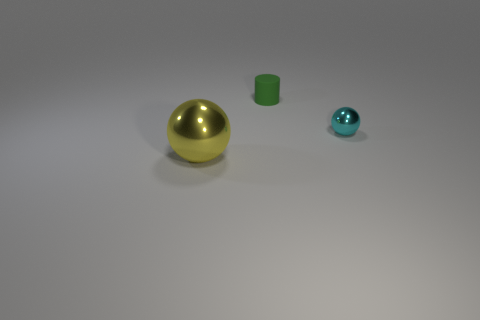What number of blocks are small yellow things or large yellow metallic things? In the image, there are no blocks that are small and yellow or large, yellow, and metallic. However, I can see one large yellow metallic sphere, one small green block, and one small blue metallic sphere. 